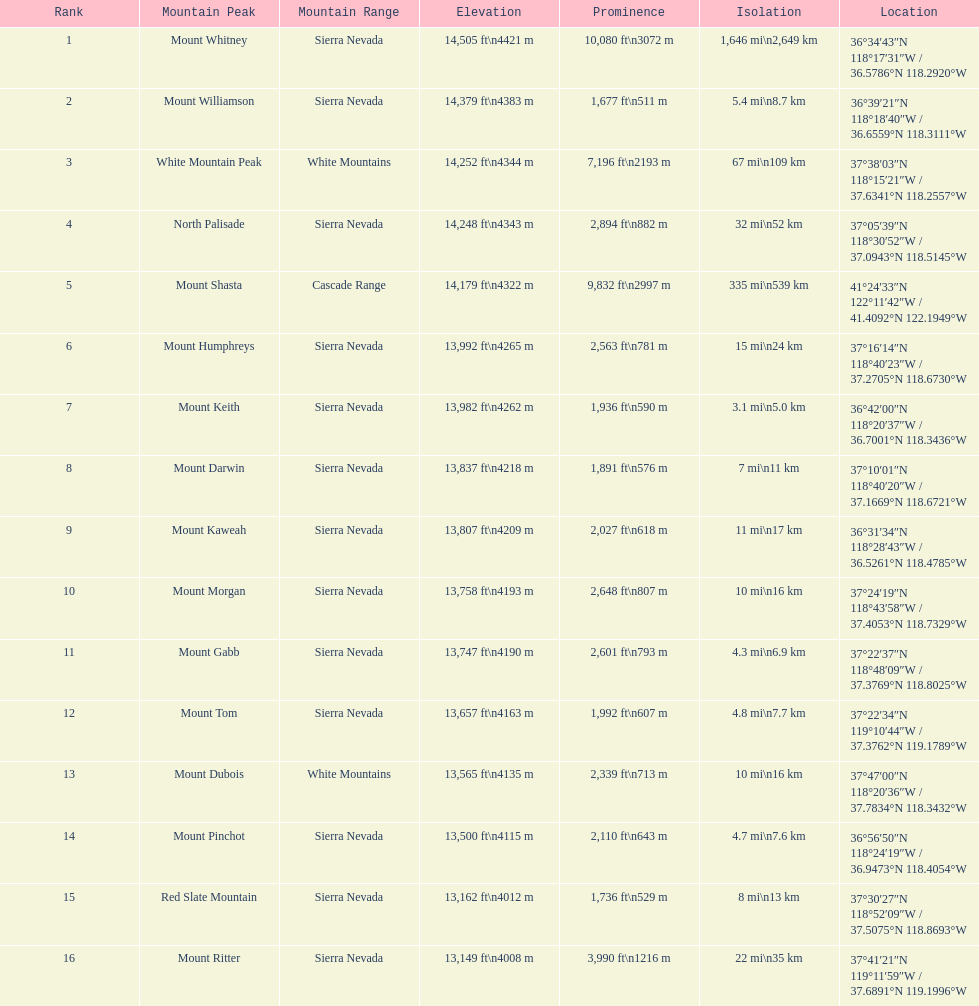Is the peak of mount keith above or below the peak of north palisade? Below. 